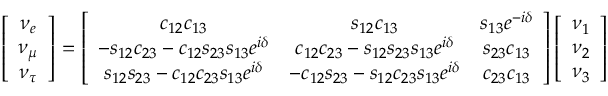Convert formula to latex. <formula><loc_0><loc_0><loc_500><loc_500>\left [ \begin{array} { c c } { { \nu _ { e } } } \\ { { \nu _ { \mu } } } \\ { { \nu _ { \tau } } } \end{array} \right ] = \left [ \begin{array} { c c c } { { c _ { 1 2 } c _ { 1 3 } } } & { { s _ { 1 2 } c _ { 1 3 } } } & { { s _ { 1 3 } e ^ { - i \delta } } } \\ { { - s _ { 1 2 } c _ { 2 3 } - c _ { 1 2 } s _ { 2 3 } s _ { 1 3 } e ^ { i \delta } } } & { { c _ { 1 2 } c _ { 2 3 } - s _ { 1 2 } s _ { 2 3 } s _ { 1 3 } e ^ { i \delta } } } & { { s _ { 2 3 } c _ { 1 3 } } } \\ { { s _ { 1 2 } s _ { 2 3 } - c _ { 1 2 } c _ { 2 3 } s _ { 1 3 } e ^ { i \delta } } } & { { - c _ { 1 2 } s _ { 2 3 } - s _ { 1 2 } c _ { 2 3 } s _ { 1 3 } e ^ { i \delta } } } & { { c _ { 2 3 } c _ { 1 3 } } } \end{array} \right ] \left [ \begin{array} { c c } { { \nu _ { 1 } } } \\ { { \nu _ { 2 } } } \\ { { \nu _ { 3 } } } \end{array} \right ]</formula> 